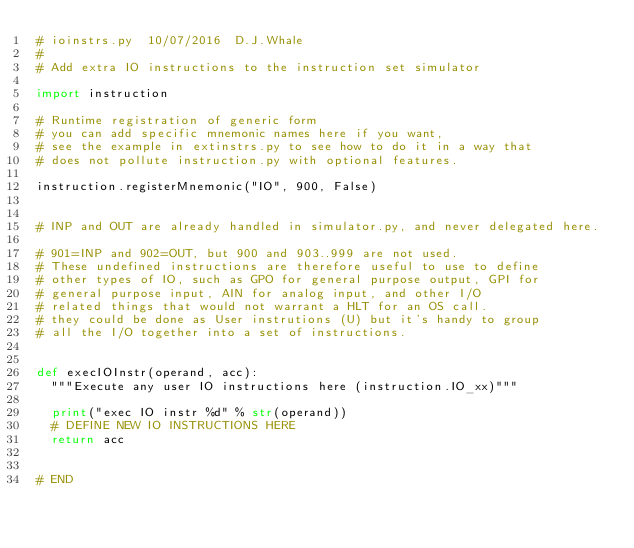Convert code to text. <code><loc_0><loc_0><loc_500><loc_500><_Python_># ioinstrs.py  10/07/2016  D.J.Whale
#
# Add extra IO instructions to the instruction set simulator

import instruction

# Runtime registration of generic form
# you can add specific mnemonic names here if you want,
# see the example in extinstrs.py to see how to do it in a way that
# does not pollute instruction.py with optional features.

instruction.registerMnemonic("IO", 900, False)


# INP and OUT are already handled in simulator.py, and never delegated here.

# 901=INP and 902=OUT, but 900 and 903..999 are not used.
# These undefined instructions are therefore useful to use to define
# other types of IO, such as GPO for general purpose output, GPI for
# general purpose input, AIN for analog input, and other I/O
# related things that would not warrant a HLT for an OS call.
# they could be done as User instrutions (U) but it's handy to group
# all the I/O together into a set of instructions.


def execIOInstr(operand, acc):
	"""Execute any user IO instructions here (instruction.IO_xx)"""

	print("exec IO instr %d" % str(operand))
	# DEFINE NEW IO INSTRUCTIONS HERE
	return acc


# END
</code> 